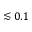Convert formula to latex. <formula><loc_0><loc_0><loc_500><loc_500>\lesssim 0 . 1</formula> 